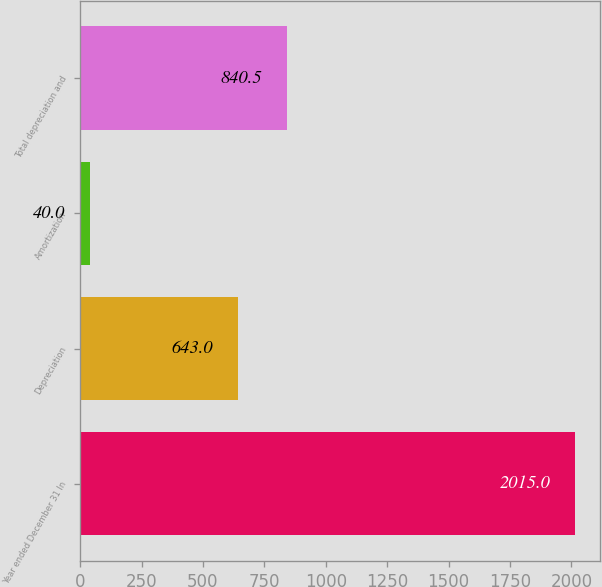<chart> <loc_0><loc_0><loc_500><loc_500><bar_chart><fcel>Year ended December 31 In<fcel>Depreciation<fcel>Amortization<fcel>Total depreciation and<nl><fcel>2015<fcel>643<fcel>40<fcel>840.5<nl></chart> 